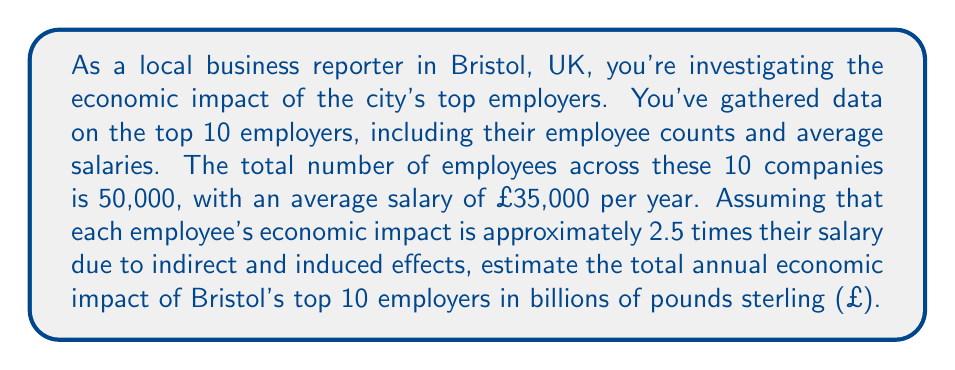Solve this math problem. To solve this problem, we'll follow these steps:

1. Calculate the total annual salary expenditure:
   $$ \text{Total Salary} = \text{Number of Employees} \times \text{Average Salary} $$
   $$ \text{Total Salary} = 50,000 \times £35,000 = £1,750,000,000 $$

2. Apply the economic impact multiplier:
   $$ \text{Economic Impact} = \text{Total Salary} \times \text{Impact Multiplier} $$
   $$ \text{Economic Impact} = £1,750,000,000 \times 2.5 = £4,375,000,000 $$

3. Convert the result to billions:
   $$ \text{Economic Impact (in billions)} = \frac{£4,375,000,000}{1,000,000,000} = £4.375 \text{ billion} $$

Therefore, the estimated total annual economic impact of Bristol's top 10 employers is £4.375 billion.
Answer: £4.375 billion 